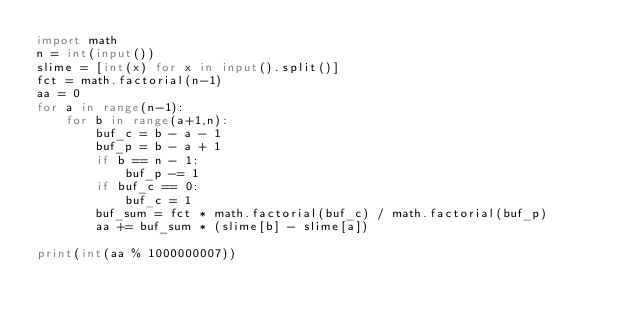<code> <loc_0><loc_0><loc_500><loc_500><_Python_>import math
n = int(input())
slime = [int(x) for x in input().split()]
fct = math.factorial(n-1)
aa = 0
for a in range(n-1):
    for b in range(a+1,n):
        buf_c = b - a - 1
        buf_p = b - a + 1
        if b == n - 1:
            buf_p -= 1
        if buf_c == 0:
            buf_c = 1
        buf_sum = fct * math.factorial(buf_c) / math.factorial(buf_p)
        aa += buf_sum * (slime[b] - slime[a])

print(int(aa % 1000000007))</code> 